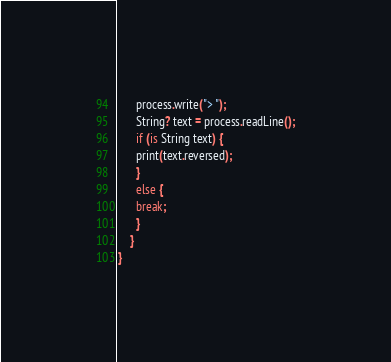<code> <loc_0><loc_0><loc_500><loc_500><_Ceylon_>      process.write("> ");
      String? text = process.readLine();
      if (is String text) {
      print(text.reversed);
      }
      else {
      break;
      }
    }
}
</code> 